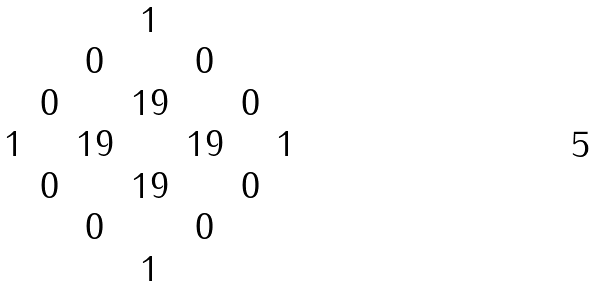Convert formula to latex. <formula><loc_0><loc_0><loc_500><loc_500>\begin{matrix} & & & 1 & & & \\ & & 0 & & 0 & & \\ & 0 & & 1 9 & & 0 & \\ 1 & & 1 9 & & 1 9 & & 1 \\ & 0 & & 1 9 & & 0 & \\ & & 0 & & 0 & & \\ & & & 1 & & & \end{matrix}</formula> 